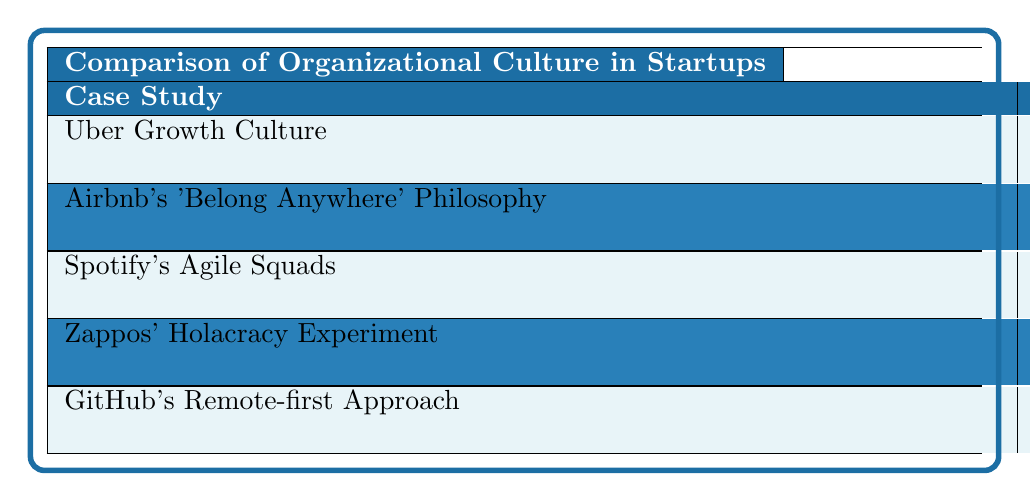What is the employee retention rate for Spotify's Agile Squads? The table shows each case study along with the respective employee retention rates. For Spotify's Agile Squads, the retention rate listed in the table is 85%.
Answer: 85% Which startup has the highest employee retention rate? Looking at the employee retention rates in the table, GitHub's Remote-first Approach has the highest rate at 89%.
Answer: 89% Is the founder quote for Airbnb's 'Belong Anywhere' Philosophy focused on community? The founder quote for Airbnb indicates a shared way of doing something with passion, which aligns with the emphasis on community. Therefore, it is true that the quote focuses on community.
Answer: Yes What challenges are reported by companies with a distributed workforce? The key challenge mentioned for the company with a distributed workforce is "Overcoming communication barriers in remote work," which indicates that communication issues are a significant concern.
Answer: Yes Which case study emphasizes autonomy and innovation? By examining the table, Spotify's Agile Squads highlight "Agile and autonomous teams" as the key culture element, along with quotes emphasizing autonomy and rapid innovation.
Answer: Spotify's Agile Squads What is the difference in employee retention rates between Uber Growth Culture and Zappos' Holacracy Experiment? The employee retention rate for Uber Growth Culture is 68% and for Zappos' Holacracy Experiment is 77%. The difference is calculated as 77% - 68% = 9%.
Answer: 9% Identify two challenges reported by companies focusing on community culture. For Airbnb, the challenge is "Maintaining culture as the company scales," and for Zappos, a challenge related to their culture is "Adapting to non-traditional organizational structure."
Answer: Maintaining culture as the company scales and Adapting to non-traditional organizational structure What cultural element is primarily associated with GitHub's approach? The table indicates that GitHub's Remote-first Approach prioritizes "Distributed workforce and asynchronous communication" as its key culture element.
Answer: Distributed workforce and asynchronous communication How many companies reported challenges related to innovation? Reviewing the challenges reported, both Spotify and Zappos have challenges focusing on innovation. Therefore, two companies reported these challenges.
Answer: 2 What is the key culture element associated with Airbnb's philosophy? The table specifies that Airbnb's culture is centered on "Fostering a sense of community," which is the key culture element for this case study.
Answer: Fostering a sense of community 